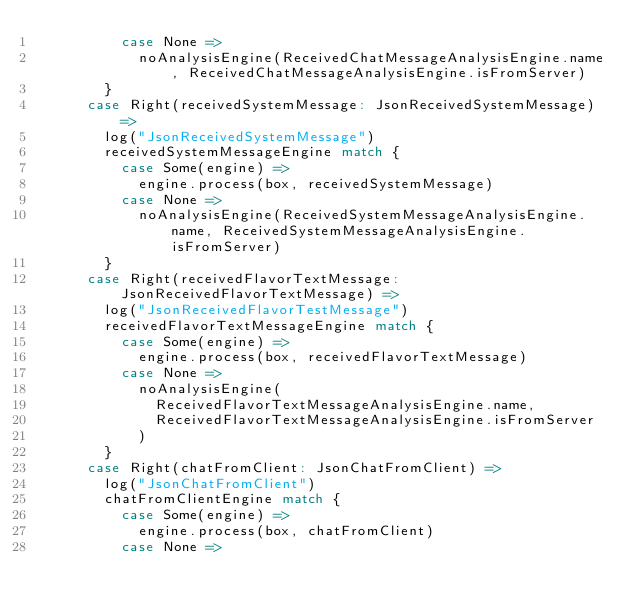Convert code to text. <code><loc_0><loc_0><loc_500><loc_500><_Scala_>          case None =>
            noAnalysisEngine(ReceivedChatMessageAnalysisEngine.name, ReceivedChatMessageAnalysisEngine.isFromServer)
        }
      case Right(receivedSystemMessage: JsonReceivedSystemMessage) =>
        log("JsonReceivedSystemMessage")
        receivedSystemMessageEngine match {
          case Some(engine) =>
            engine.process(box, receivedSystemMessage)
          case None =>
            noAnalysisEngine(ReceivedSystemMessageAnalysisEngine.name, ReceivedSystemMessageAnalysisEngine.isFromServer)
        }
      case Right(receivedFlavorTextMessage: JsonReceivedFlavorTextMessage) =>
        log("JsonReceivedFlavorTestMessage")
        receivedFlavorTextMessageEngine match {
          case Some(engine) =>
            engine.process(box, receivedFlavorTextMessage)
          case None =>
            noAnalysisEngine(
              ReceivedFlavorTextMessageAnalysisEngine.name,
              ReceivedFlavorTextMessageAnalysisEngine.isFromServer
            )
        }
      case Right(chatFromClient: JsonChatFromClient) =>
        log("JsonChatFromClient")
        chatFromClientEngine match {
          case Some(engine) =>
            engine.process(box, chatFromClient)
          case None =></code> 